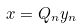<formula> <loc_0><loc_0><loc_500><loc_500>x = Q _ { n } y _ { n }</formula> 